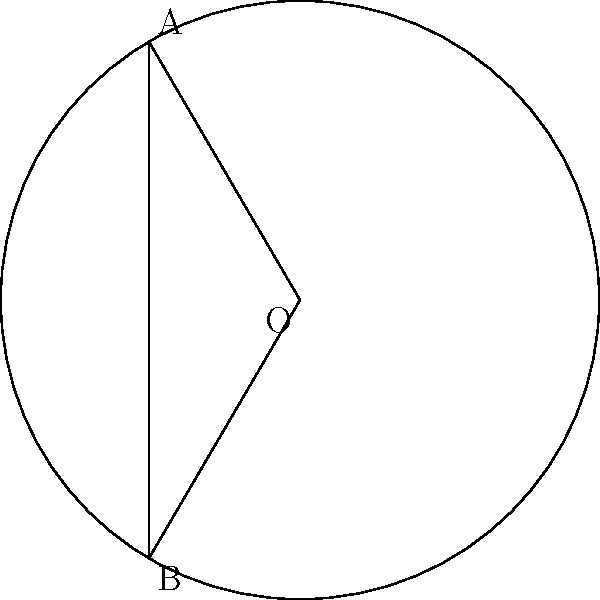During your travels in Mongolia, you noticed that traditional yurts have a circular base. Imagine a yurt with a radius of 3 meters, and a segment is cut off by a chord that subtends a central angle of 2.1 radians. Calculate the area of this circular segment, which represents the living space in the yurt. Round your answer to two decimal places. To calculate the area of the circular segment, we'll follow these steps:

1) The area of a circular segment is given by the formula:
   $$A = r^2 (\theta - \sin \theta)$$
   where $r$ is the radius and $\theta$ is the central angle in radians.

2) We're given:
   $r = 3$ meters
   $\theta = 2.1$ radians

3) Let's substitute these values into our formula:
   $$A = 3^2 (2.1 - \sin 2.1)$$

4) First, calculate $\sin 2.1$:
   $\sin 2.1 \approx 0.8632$

5) Now, we can compute:
   $$A = 9 (2.1 - 0.8632)$$
   $$A = 9 (1.2368)$$
   $$A = 11.1312$$

6) Rounding to two decimal places:
   $$A \approx 11.13$$ square meters

Therefore, the area of the circular segment representing the living space in the yurt is approximately 11.13 square meters.
Answer: 11.13 m² 